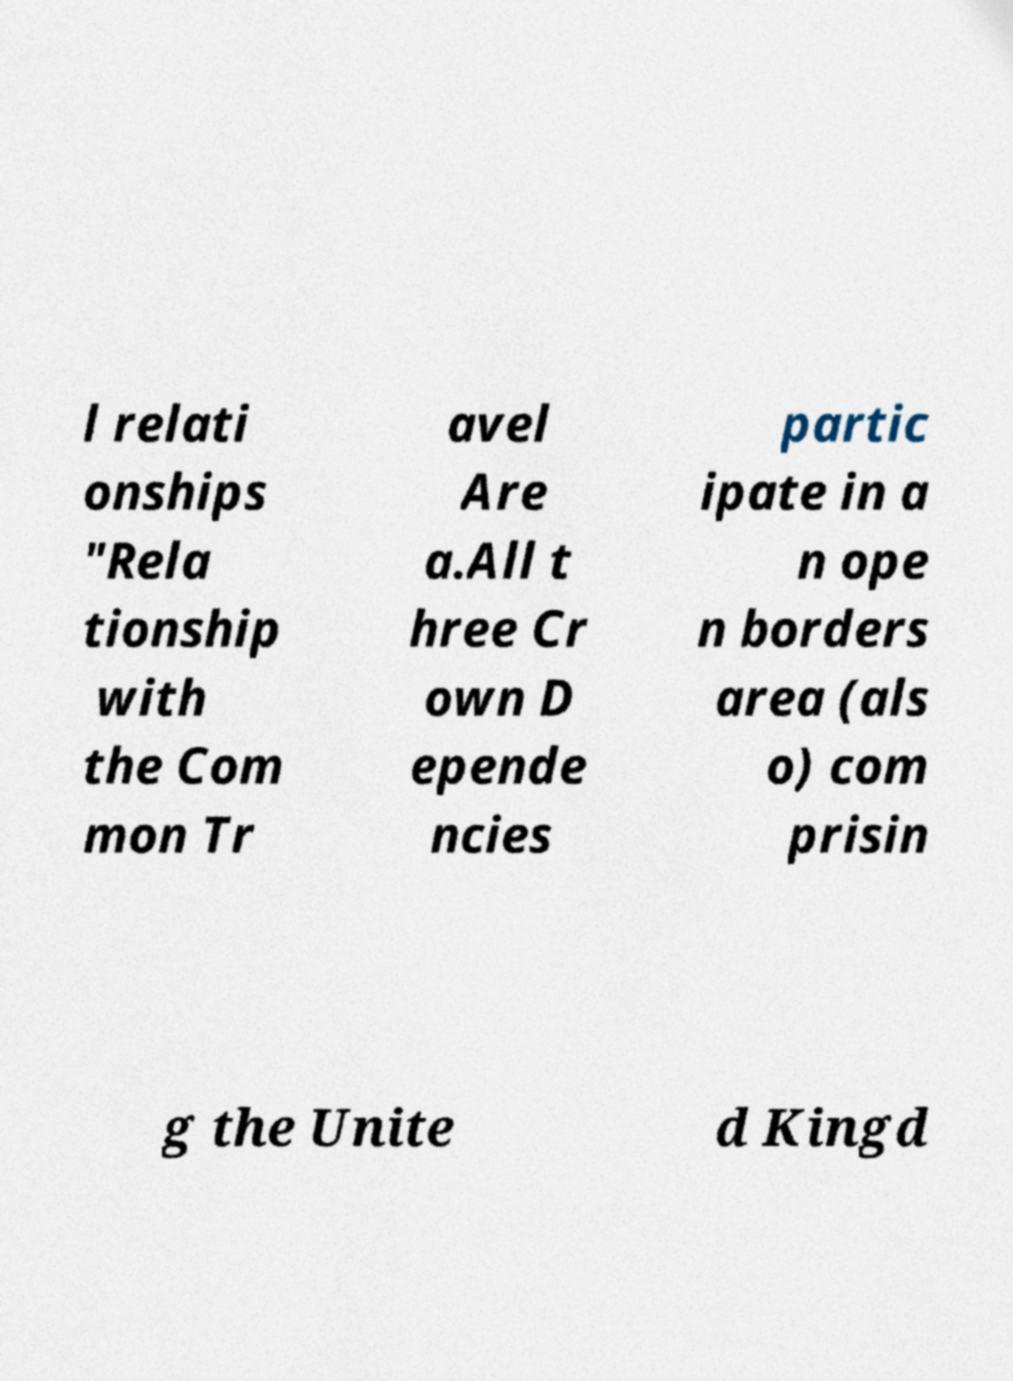Please identify and transcribe the text found in this image. l relati onships "Rela tionship with the Com mon Tr avel Are a.All t hree Cr own D epende ncies partic ipate in a n ope n borders area (als o) com prisin g the Unite d Kingd 